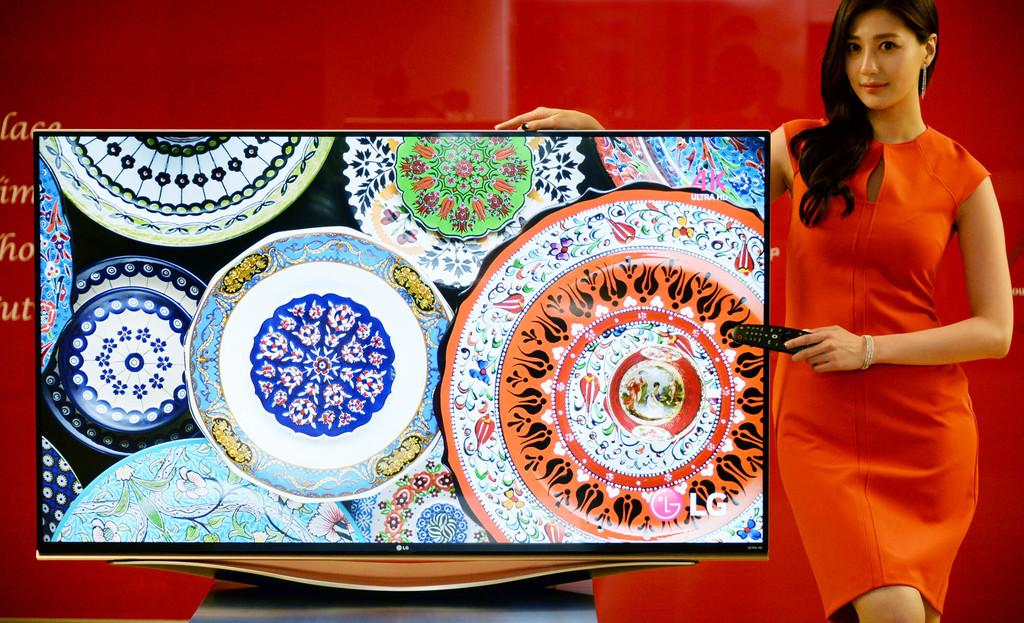What is the main object in the foreground of the image? There is a TV in the foreground of the image. What is the woman in the foreground of the image doing? The woman is holding a remote in the foreground of the image. What is the position of the woman in the image? The woman is standing in the foreground of the image. What can be seen in the background of the image? There is a colored wall in the background of the image. What type of location might the image have been taken in? The image may have been taken in a hall. What type of plot is being discussed by the woman and her father in the image? There is no mention of a father or a plot in the image; it features a woman holding a remote in front of a TV. 